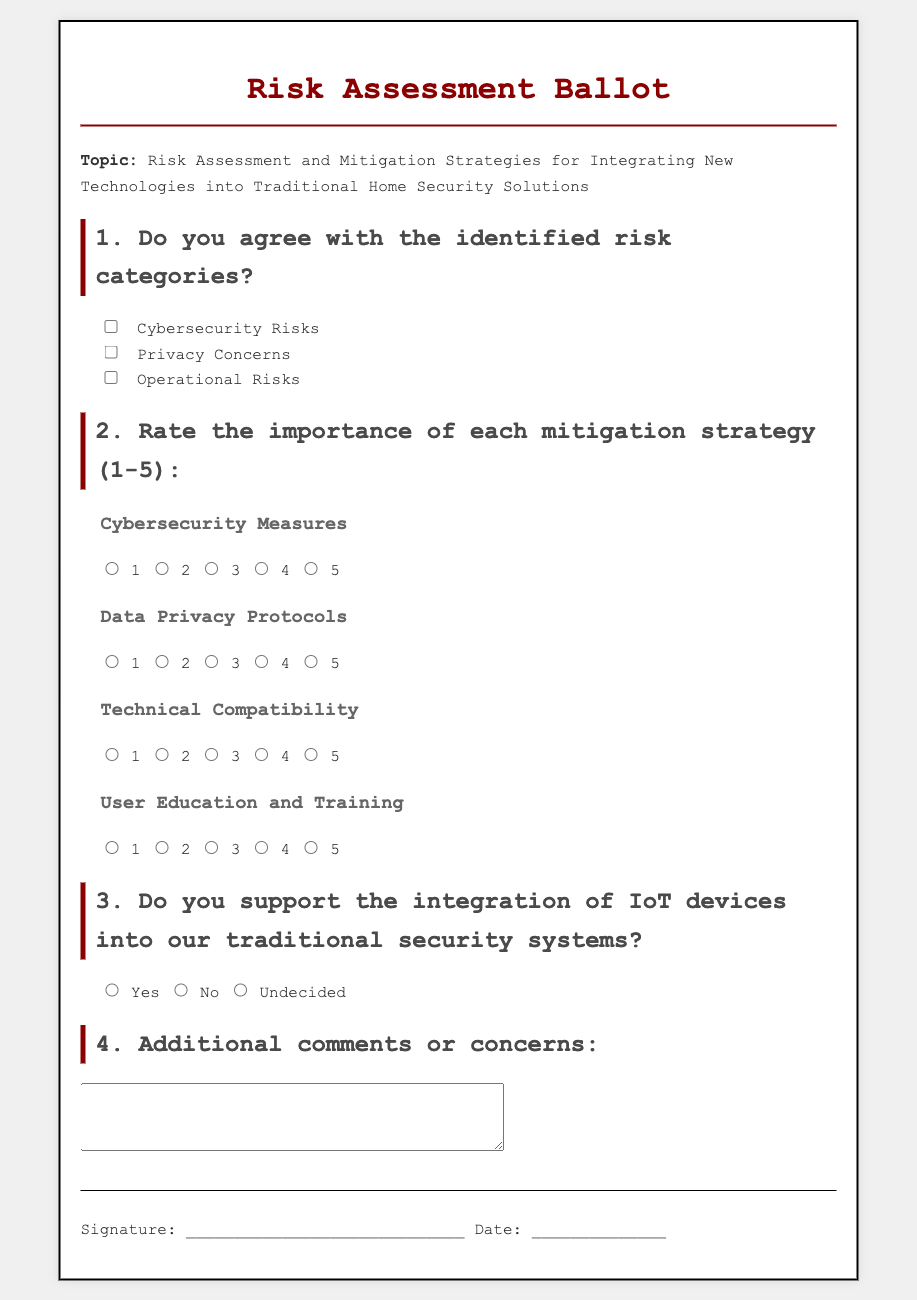What is the topic of the ballot? The topic is explicitly stated at the beginning of the ballot document.
Answer: Risk Assessment and Mitigation Strategies for Integrating New Technologies into Traditional Home Security Solutions How many risk categories are identified? The document lists three risk categories under question 1, which can be counted.
Answer: 3 What is the highest rating on the scale for mitigation strategies? The document specifies a rating scale from 1 to 5 for each mitigation strategy, making it clear what the highest rating is.
Answer: 5 What category includes Cybersecurity Measures? The document lists Cybersecurity Measures under the importance rating section, indicating it relates to the security risks identified.
Answer: Cybersecurity Risks What response options are provided for the support of IoT device integration? The document contains three specific options related to support for IoT devices under section 3.
Answer: Yes, No, Undecided What is needed for the signature section? The document includes a portion for signing and dating, indicating what is required in this section.
Answer: Signature and Date What is the purpose of the additional comments section? The document includes an open field for providing further feedback or concerns, implying its intended use.
Answer: Feedback or concerns What subsections are included under importance ratings? The document outlines several subsections, specifically indicating the different areas needing ratings.
Answer: Cybersecurity Measures, Data Privacy Protocols, Technical Compatibility, User Education and Training Which risk category directly relates to the user's private data? The document outlines specific risks, and Privacy Concerns directly relates to this issue, as indicated in section 1.
Answer: Privacy Concerns 